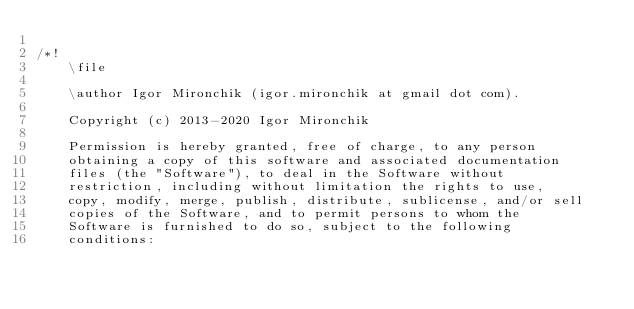Convert code to text. <code><loc_0><loc_0><loc_500><loc_500><_C++_>
/*!
	\file

	\author Igor Mironchik (igor.mironchik at gmail dot com).

	Copyright (c) 2013-2020 Igor Mironchik

	Permission is hereby granted, free of charge, to any person
	obtaining a copy of this software and associated documentation
	files (the "Software"), to deal in the Software without
	restriction, including without limitation the rights to use,
	copy, modify, merge, publish, distribute, sublicense, and/or sell
	copies of the Software, and to permit persons to whom the
	Software is furnished to do so, subject to the following
	conditions:
</code> 